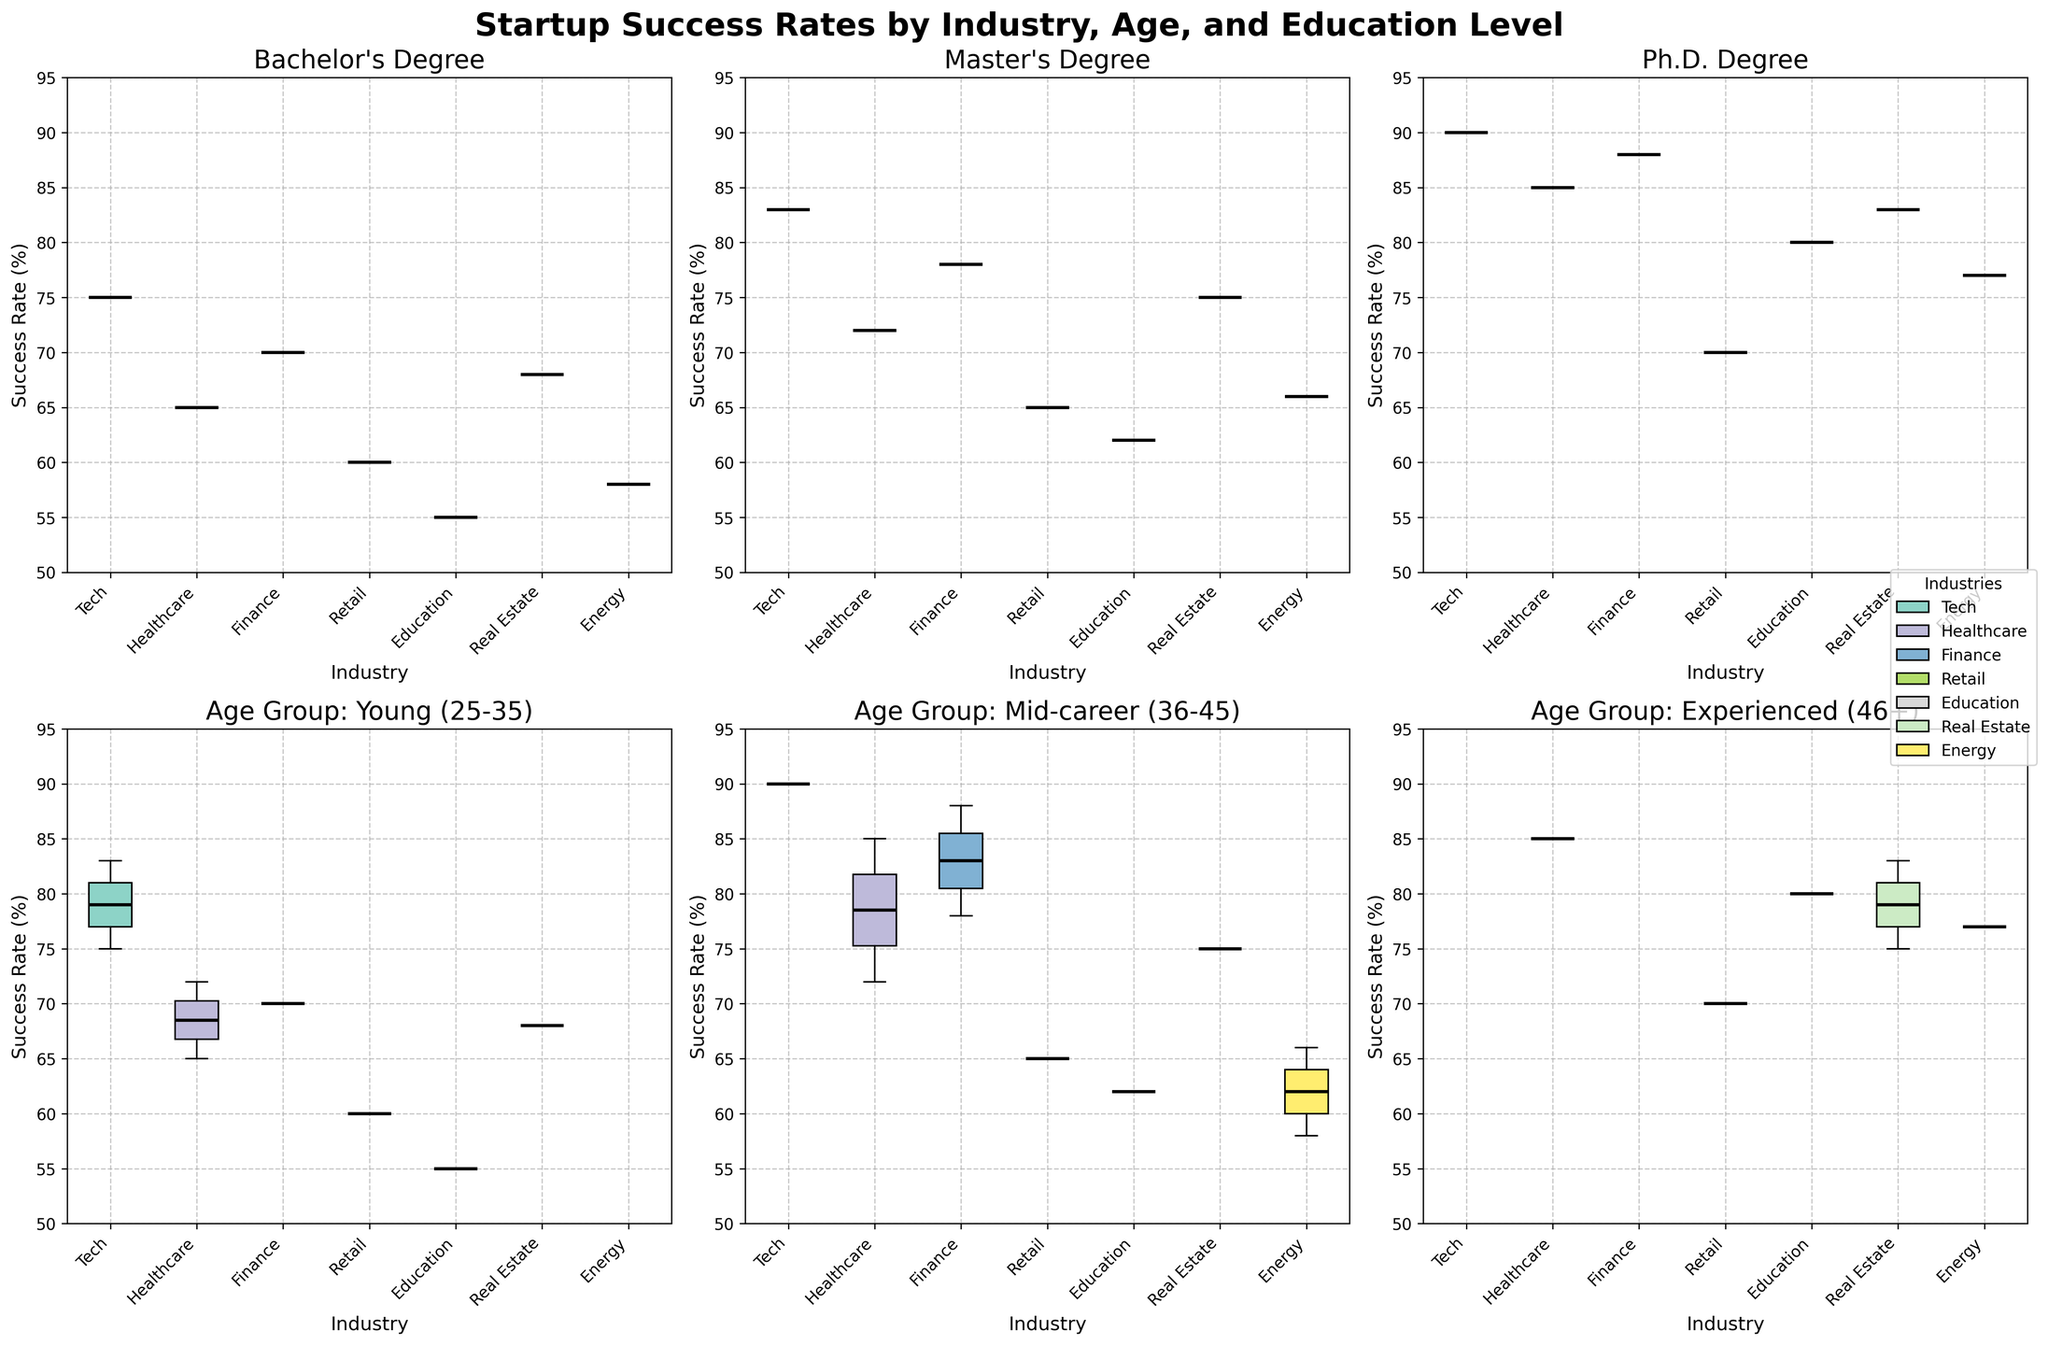What's the title of the figure? The title is usually found at the top-center of the figure. In this case, the title reads "Startup Success Rates by Industry, Age, and Education Level".
Answer: Startup Success Rates by Industry, Age, and Education Level Which industry has the highest median success rate for founders with a Ph.D. degree? To find this information, locate the subplot titled "Ph.D. Degree". Within this subplot, each box plot represents a different industry. The highest median is indicated by the thick central line in the box plot. The "Tech" industry shows the highest median success rate.
Answer: Tech What range of success rates is depicted on the y-axis for all plots? Look at the y-axis of any subplot to find the range. It starts from 50% and goes up to 95%.
Answer: 50% to 95% How does the success rate of mid-career founders (36-45) in the Healthcare industry compare to those in the Tech industry with the same age group? For this comparison, find the subplot "Age Group: Mid-career (36-45)". Within this subplot, compare the box plot for Healthcare and Tech. The median line for Healthcare is lower than that for Tech.
Answer: Lower Which education level subplot shows the greatest variance in success rates for the Real Estate industry? Check the spread of the boxplots for the Real Estate industry across different education levels. The "Bachelor's" degree subplot shows the greatest variance, as indicated by a larger spread between the lower and upper quartiles.
Answer: Bachelor's For founders aged 25-35, which industry has the least variability in success rates? Locate the subplot labeled "Age Group: Young (25-35)". Look at the width of the boxes (interquartile range, IQR) for each industry. The "Finance" industry shows the least variability.
Answer: Finance Is the median success rate higher for Ph.D. holders in Tech or Healthcare industries? Find the Ph.D. degree subplot and compare the median lines of Tech and Healthcare box plots. The Tech industry exhibits a higher median success rate than Healthcare.
Answer: Tech Between the industries, which one has the lowest overall median success rate across all age groups with a Bachelor's degree? Check the "Bachelor's Degree" subplot and compare the medians of each industry. The "Education" industry shows the lowest overall median success rate.
Answer: Education Which age group has the highest median success rate in the Energy industry? Look at the Energy industry box plots across the three age group subplots. The highest median line appears in the "Experienced (46+)" age group.
Answer: Experienced (46+) How does the success rate for Master's educated founders in Retail compare to those with Bachelor's and Ph.D. degrees in the same industry? Examine the "Master's Degree", "Bachelor's Degree", and "Ph.D. Degree" subplots for the Retail industry. The median success rate for Master's educated founders is higher than those with a Bachelor's and lower than those with a Ph.D.
Answer: Higher than Bachelor's, lower than Ph.D 